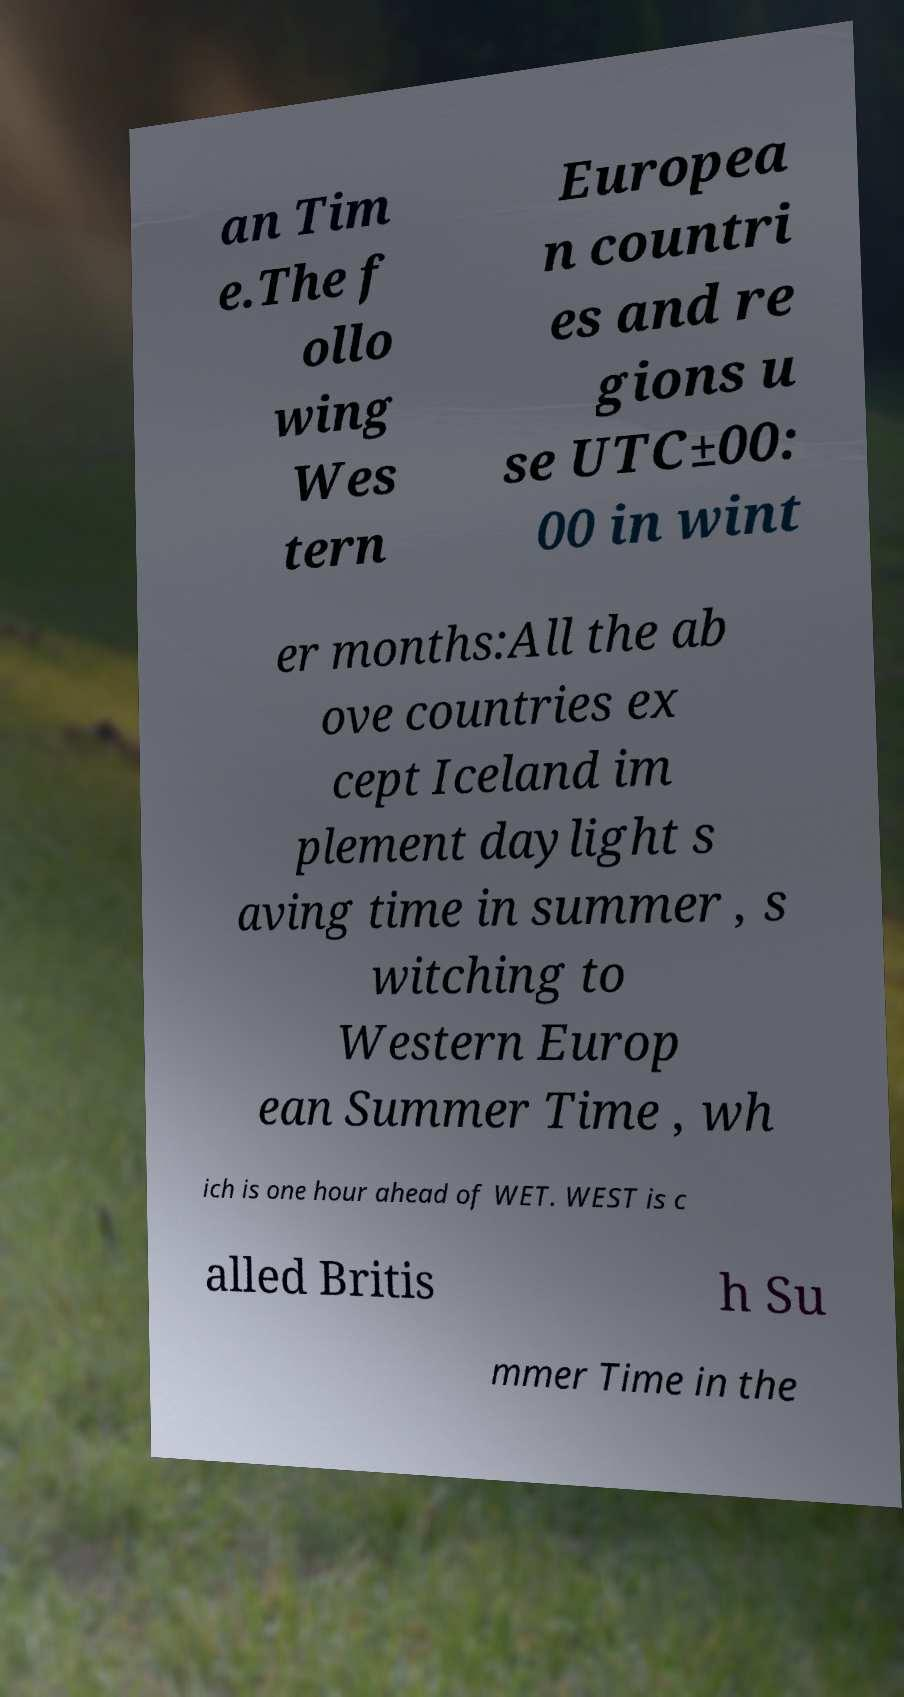For documentation purposes, I need the text within this image transcribed. Could you provide that? an Tim e.The f ollo wing Wes tern Europea n countri es and re gions u se UTC±00: 00 in wint er months:All the ab ove countries ex cept Iceland im plement daylight s aving time in summer , s witching to Western Europ ean Summer Time , wh ich is one hour ahead of WET. WEST is c alled Britis h Su mmer Time in the 